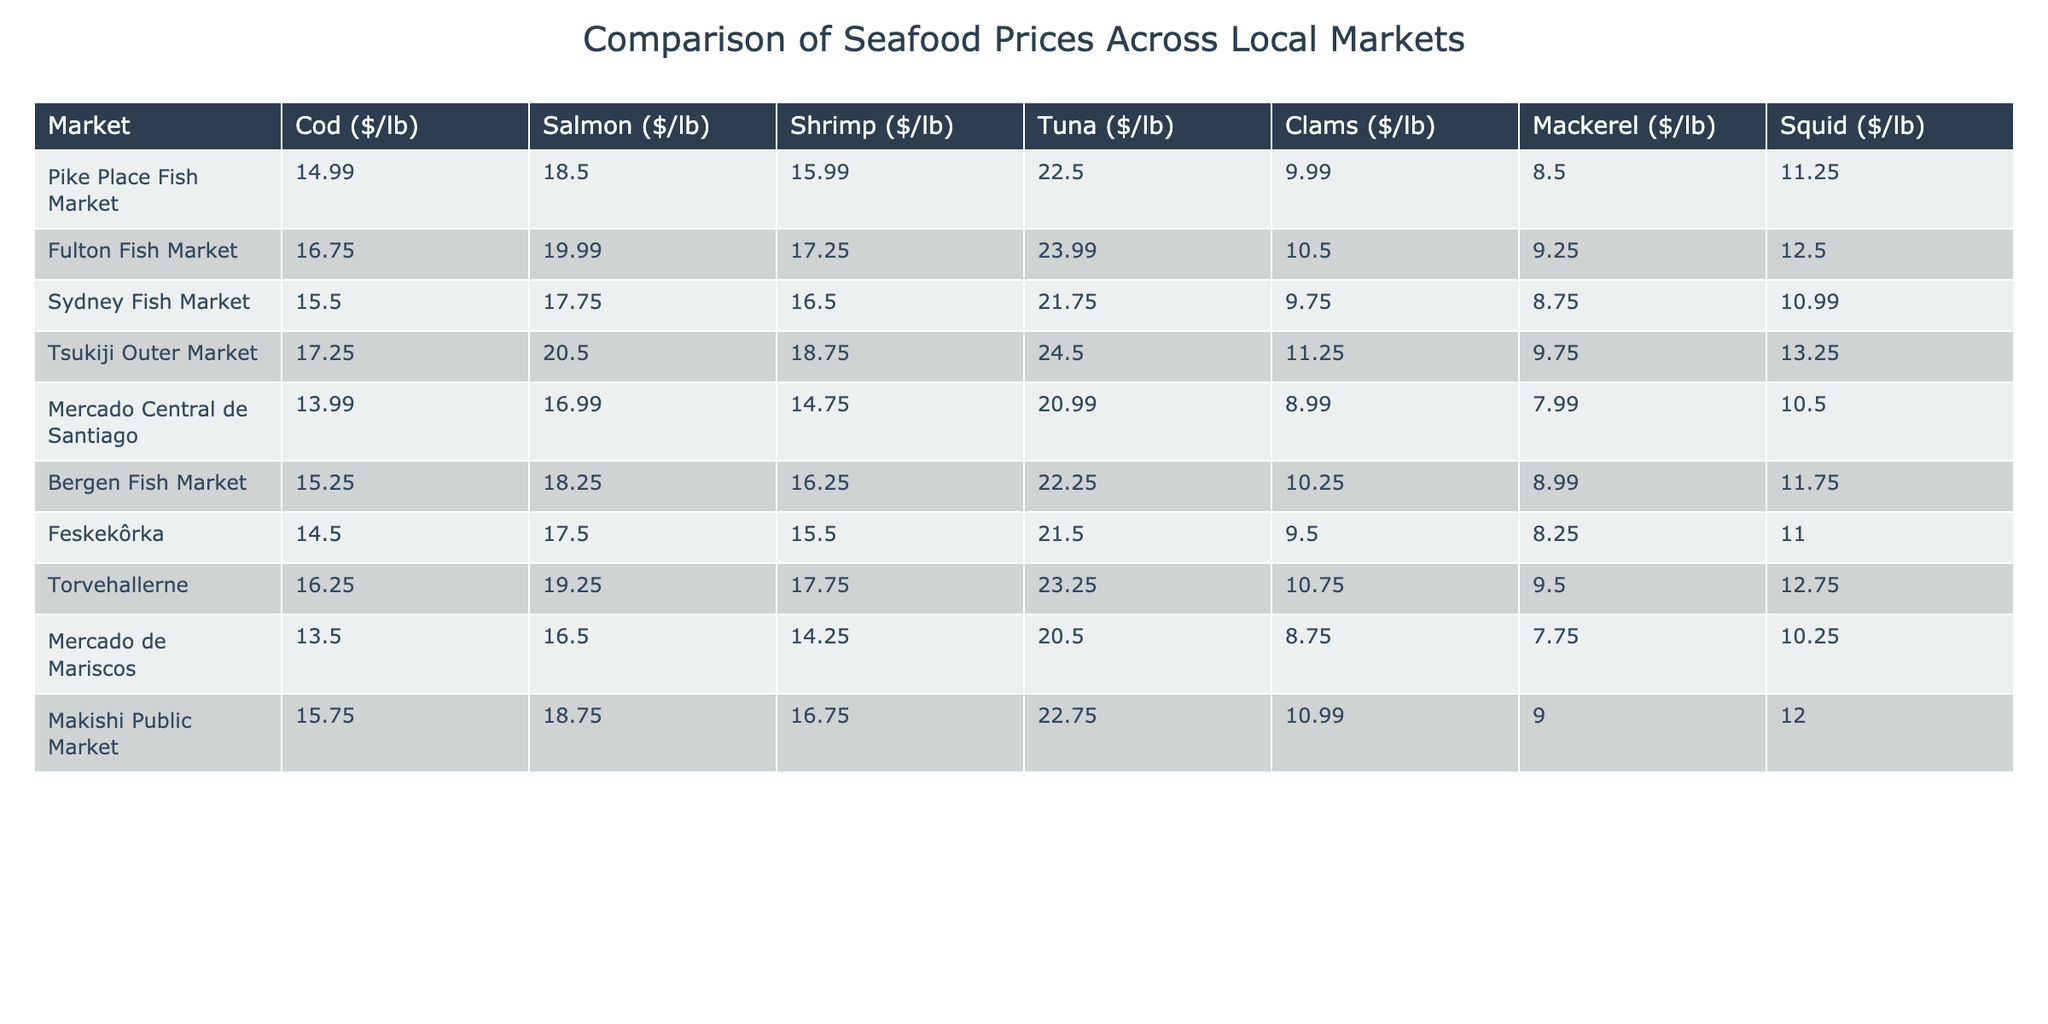What is the price of shrimp at Pike Place Fish Market? The table shows the price of shrimp specifically listed under Pike Place Fish Market, which is $15.99 per pound.
Answer: 15.99 Which market has the highest price for tuna? By comparing the tuna prices across all markets in the table, Tsukiji Outer Market has the highest price at $24.50 per pound.
Answer: Tsukiji Outer Market What is the average price of salmon across all markets? To find the average price, add all the salmon prices ($18.50 + $19.99 + $17.75 + $20.50 + $16.99 + $18.25 + $17.50 + $19.25 + $18.75) which equals $149.50, and then divide by 9 (the number of markets), which equals approximately $16.61.
Answer: 18.61 Is the price of clams at Mercado Central de Santiago higher than at Feskekôrka? The price of clams at Mercado Central de Santiago is $8.99, and at Feskekôrka, it is $9.50. Since $8.99 is less than $9.50, the statement is false.
Answer: No What is the difference in price between cod at the highest and lowest priced markets? The highest cod price is at Tsukiji Outer Market ($17.25) and the lowest is at Mercado Central de Santiago ($13.99). The difference is calculated as $17.25 - $13.99 = $3.26.
Answer: 3.26 Which market offers squid at the lowest price? Checking all listed squid prices, Mercado de Mariscos has the lowest price at $10.25 per pound.
Answer: Mercado de Mariscos How much more expensive is salmon at Fulton Fish Market compared to Mercado Central de Santiago? The price at Fulton Fish Market is $19.99 and at Mercado Central de Santiago is $16.99. The difference is $19.99 - $16.99 = $3.00.
Answer: 3.00 What is the total cost of purchasing 2 lbs of shrimp from each market? To find the total cost for shrimp at each market, multiply the price per pound by 2 for each market and then sum them up: (2 * 15.99 + 2 * 17.25 + 2 * 16.50 + 2 * 18.75 + 2 * 14.75 + 2 * 16.25 + 2 * 15.50 + 2 * 17.75 + 2 * 16.75), which equals $218.00.
Answer: 218.00 Which market has a higher price for mackerel: Makishi Public Market or Bergen Fish Market? The price at Makishi Public Market is $9.00 and at Bergen Fish Market, it is $8.99. Since $9.00 is higher than $8.99, Makishi Public Market has a higher price for mackerel.
Answer: Yes What percentage of the prices of tuna is higher than $22 per pound? The markets with tuna prices higher than $22 are Tsukiji Outer Market ($24.50) and Fulton Fish Market ($23.99), so that makes 2 out of 9 total markets: (2/9) * 100 = 22.22%.
Answer: 22.22% 